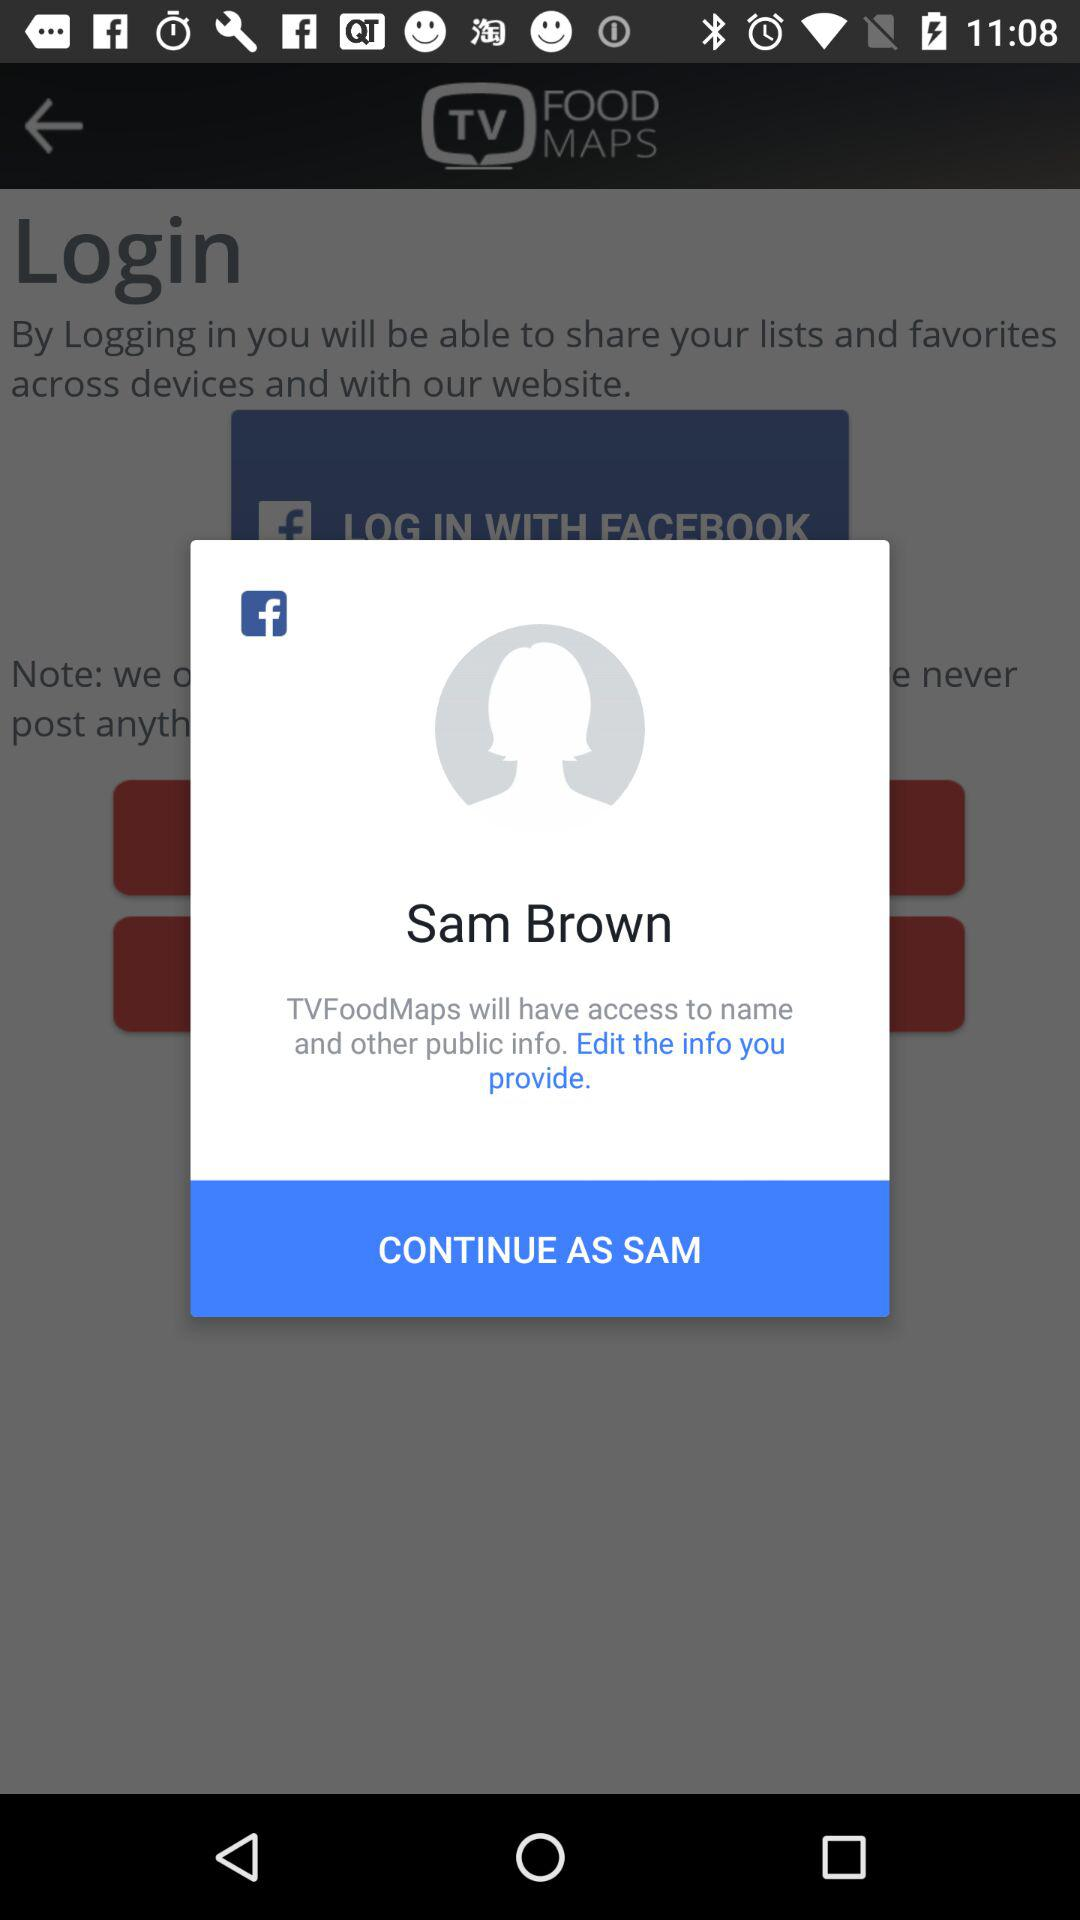What applications are we logging in with? You are logging in with "FACEBOOK". 